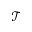Convert formula to latex. <formula><loc_0><loc_0><loc_500><loc_500>\mathcal { T }</formula> 